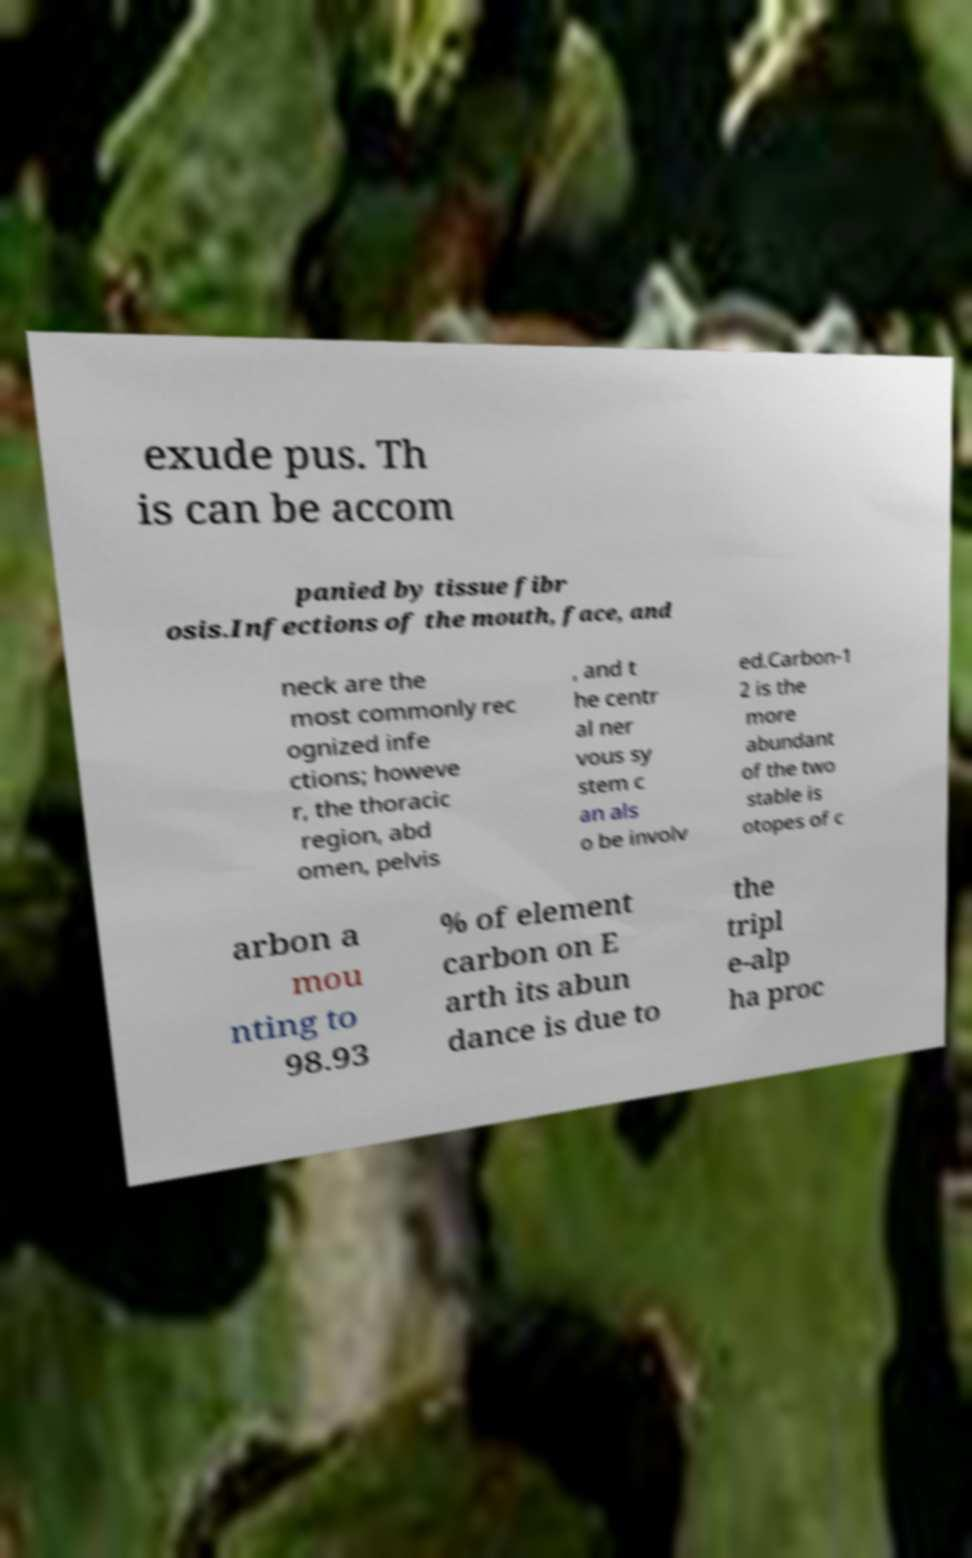I need the written content from this picture converted into text. Can you do that? exude pus. Th is can be accom panied by tissue fibr osis.Infections of the mouth, face, and neck are the most commonly rec ognized infe ctions; howeve r, the thoracic region, abd omen, pelvis , and t he centr al ner vous sy stem c an als o be involv ed.Carbon-1 2 is the more abundant of the two stable is otopes of c arbon a mou nting to 98.93 % of element carbon on E arth its abun dance is due to the tripl e-alp ha proc 